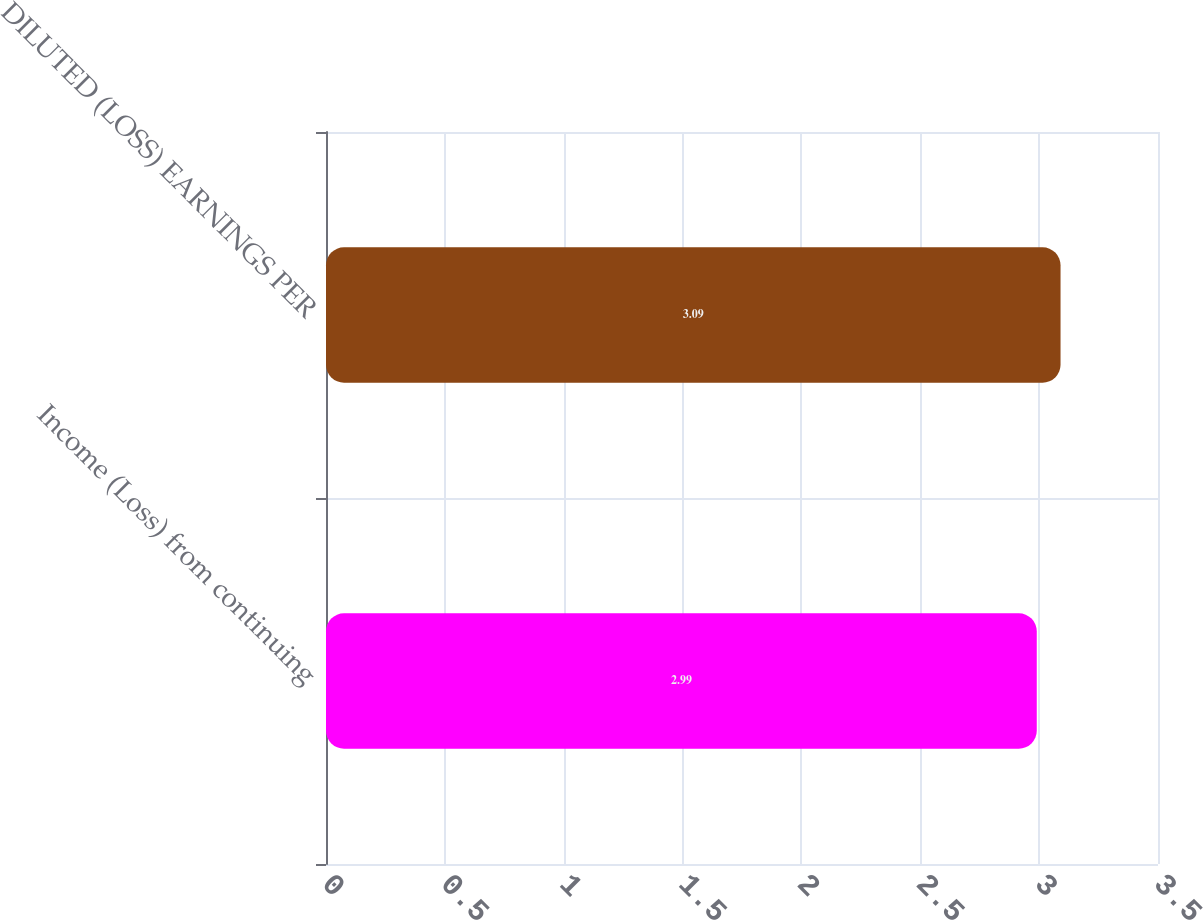Convert chart. <chart><loc_0><loc_0><loc_500><loc_500><bar_chart><fcel>Income (Loss) from continuing<fcel>DILUTED (LOSS) EARNINGS PER<nl><fcel>2.99<fcel>3.09<nl></chart> 